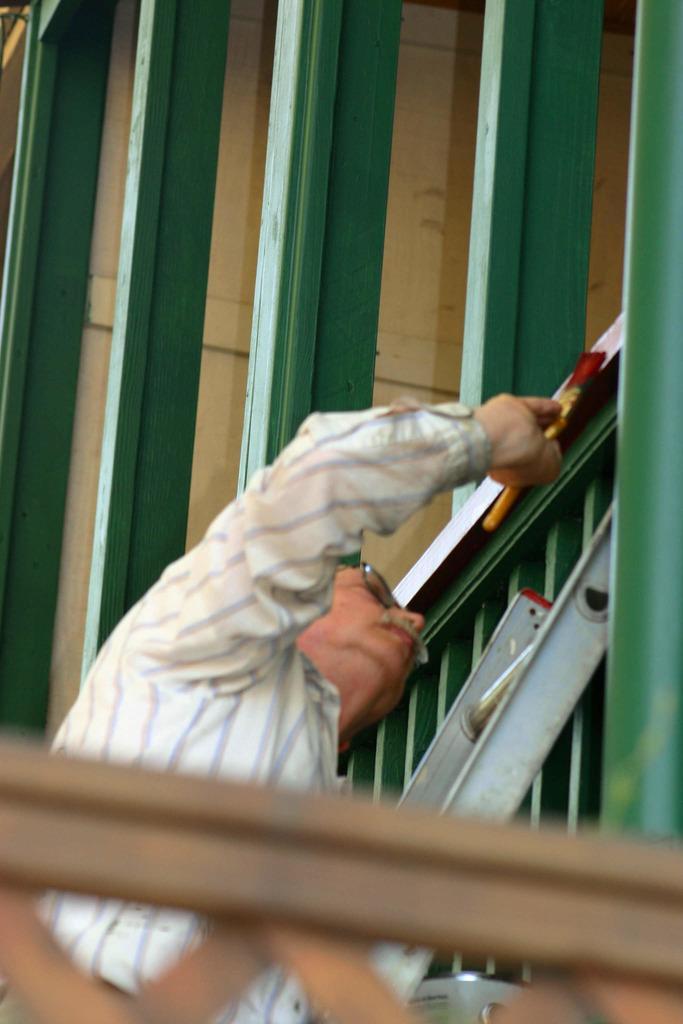Please provide a concise description of this image. In this image we can see a man and wooden grills. 